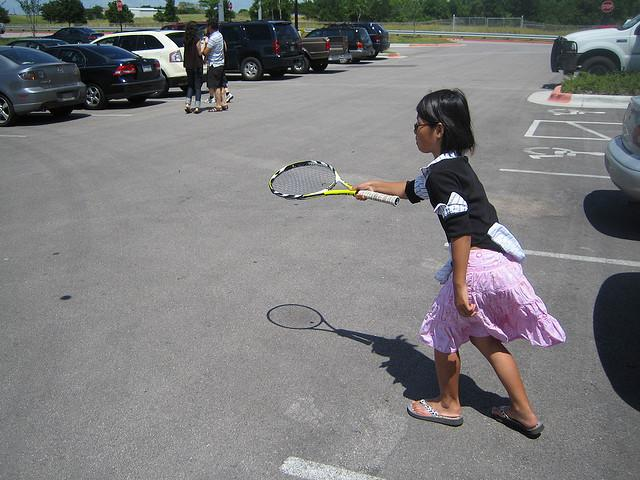Who plays the same sport? Please explain your reasoning. serena williams. The girl is holding a tennis racquet, not a baseball bat, steering wheel, or soccer ball. 